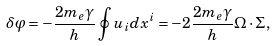<formula> <loc_0><loc_0><loc_500><loc_500>\delta \varphi = - \frac { 2 m _ { e } \gamma } { h } \oint u _ { i } d x ^ { i } = - 2 \frac { 2 m _ { e } \gamma } { h } { \Omega } \cdot { \Sigma } ,</formula> 